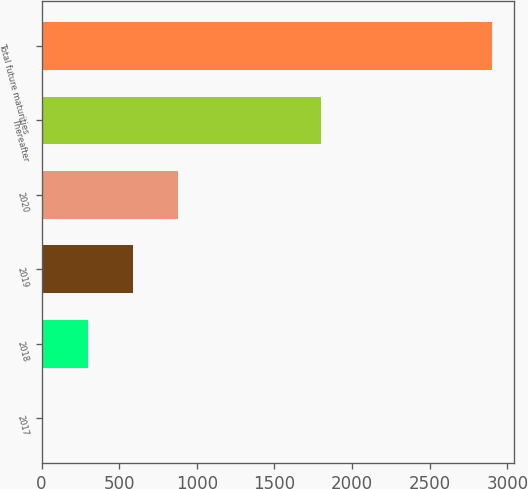Convert chart to OTSL. <chart><loc_0><loc_0><loc_500><loc_500><bar_chart><fcel>2017<fcel>2018<fcel>2019<fcel>2020<fcel>Thereafter<fcel>Total future maturities<nl><fcel>12<fcel>300.7<fcel>589.4<fcel>878.1<fcel>1800<fcel>2899<nl></chart> 